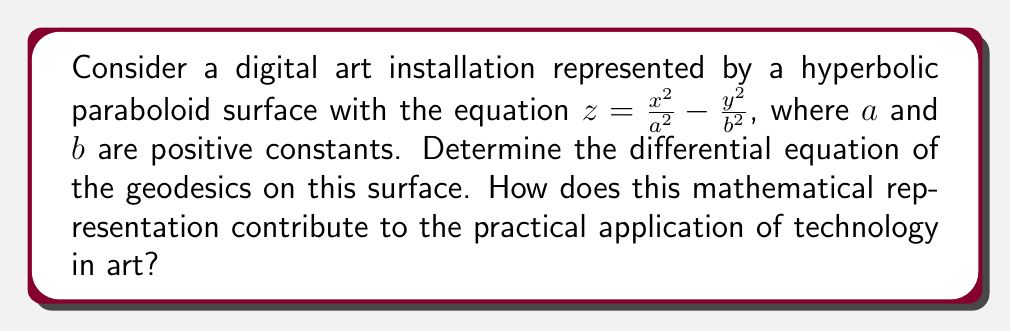Solve this math problem. To find the differential equation of geodesics on the given surface, we'll follow these steps:

1) First, we need to calculate the coefficients of the first fundamental form:
   $$E = 1 + (\frac{\partial z}{\partial x})^2 = 1 + \frac{4x^2}{a^4}$$
   $$F = \frac{\partial z}{\partial x} \frac{\partial z}{\partial y} = -\frac{4xy}{a^2b^2}$$
   $$G = 1 + (\frac{\partial z}{\partial y})^2 = 1 + \frac{4y^2}{b^4}$$

2) Next, we calculate the Christoffel symbols:
   $$\Gamma_{11}^1 = \frac{GE_x - 2FF_x + FE_y}{2(EG-F^2)}$$
   $$\Gamma_{12}^1 = \frac{GE_y - FG_x}{2(EG-F^2)}$$
   $$\Gamma_{22}^1 = \frac{2FG_y - GG_x}{2(EG-F^2)}$$
   $$\Gamma_{11}^2 = \frac{2EF_x - EE_y}{2(EG-F^2)}$$
   $$\Gamma_{12}^2 = \frac{EG_x - FE_y}{2(EG-F^2)}$$
   $$\Gamma_{22}^2 = \frac{EG_y - 2FF_y + FG_x}{2(EG-F^2)}$$

3) The differential equations of geodesics are:
   $$\frac{d^2x}{ds^2} + \Gamma_{11}^1(\frac{dx}{ds})^2 + 2\Gamma_{12}^1\frac{dx}{ds}\frac{dy}{ds} + \Gamma_{22}^1(\frac{dy}{ds})^2 = 0$$
   $$\frac{d^2y}{ds^2} + \Gamma_{11}^2(\frac{dx}{ds})^2 + 2\Gamma_{12}^2\frac{dx}{ds}\frac{dy}{ds} + \Gamma_{22}^2(\frac{dy}{ds})^2 = 0$$

4) Substituting the Christoffel symbols and simplifying, we get the differential equations of geodesics on this surface.

This mathematical representation contributes to the practical application of technology in art by:
1) Providing a precise description of the art installation's shape.
2) Allowing for accurate computer modeling and rendering of the installation.
3) Enabling the calculation of optimal paths on the surface, which could be used for lighting, viewer navigation, or other interactive elements.
4) Facilitating the integration of the physical structure with digital elements by providing a mathematical basis for mapping projections or other digital overlays onto the surface.
Answer: The differential equations of geodesics on the hyperbolic paraboloid surface $z = \frac{x^2}{a^2} - \frac{y^2}{b^2}$. 